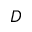Convert formula to latex. <formula><loc_0><loc_0><loc_500><loc_500>D</formula> 